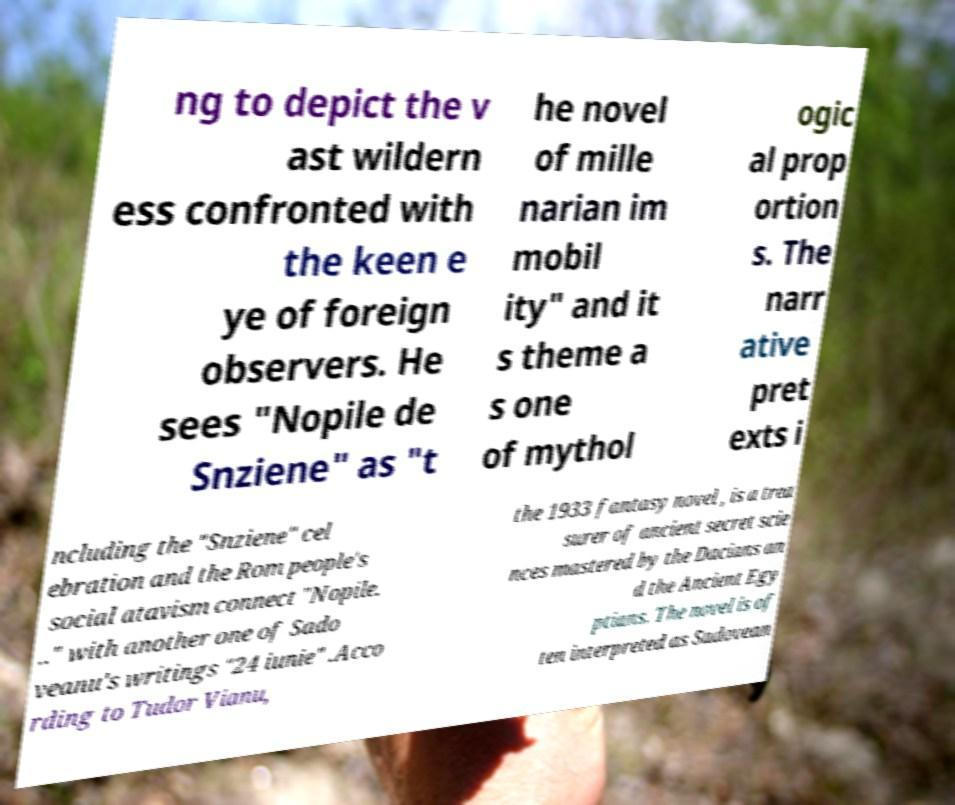Please identify and transcribe the text found in this image. ng to depict the v ast wildern ess confronted with the keen e ye of foreign observers. He sees "Nopile de Snziene" as "t he novel of mille narian im mobil ity" and it s theme a s one of mythol ogic al prop ortion s. The narr ative pret exts i ncluding the "Snziene" cel ebration and the Rom people's social atavism connect "Nopile. .." with another one of Sado veanu's writings "24 iunie" .Acco rding to Tudor Vianu, the 1933 fantasy novel , is a trea surer of ancient secret scie nces mastered by the Dacians an d the Ancient Egy ptians. The novel is of ten interpreted as Sadovean 